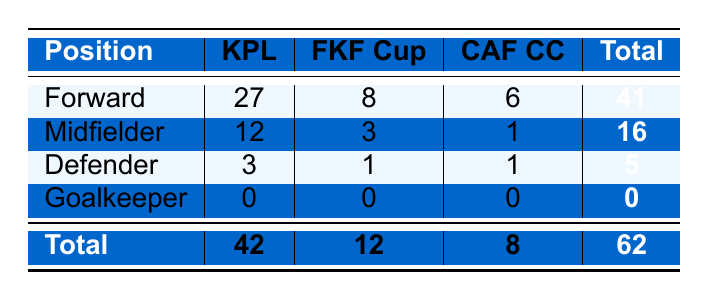What is the total number of goals scored by Kibera Black Stars in the Kenyan Premier League? From the table, the total goals scored by the team in the Kenyan Premier League is indicated in the row for "Total," which shows 42 goals.
Answer: 42 How many goals did midfielders score in the FKF Cup? The row for midfielders shows the FKF Cup goals, which is 3.
Answer: 3 Who scored more goals in the CAF Confederation Cup, forwards or midfielders? Forwards scored 6 goals in the CAF Confederation Cup while midfielders only scored 1 goal. This means forwards scored more.
Answer: Forwards What is the combined total of goals scored by defenders in all competitions? The table shows that defenders scored 3 goals in the Kenyan Premier League, 1 in the FKF Cup, and 1 in the CAF Confederation Cup. Adding these gives 3 + 1 + 1 = 5.
Answer: 5 How many total goals did the Kibera Black Stars score across all competitions? The "Total" row in the table shows the overall number of goals scored by Kibera Black Stars, which is 62.
Answer: 62 Did any goalkeepers score goals for Kibera Black Stars in any competition? The table shows that the row for goalkeepers indicates 0 goals in all competitions, confirming that no goalkeeper scored any goals.
Answer: No Which position has the highest total number of goals scored? Looking at the total goals for each position, forwards with 41 goals have the highest total, followed by midfielders with 16, defenders with 5, and goalkeepers with 0.
Answer: Forwards What is the ratio of goals scored by defenders to those scored by midfielders in the Kenyan Premier League? Defenders scored 3 goals and midfielders scored 12 goals in the Kenyan Premier League. The ratio is 3:12, which simplifies to 1:4.
Answer: 1:4 If a forward scored 1 more goal in the FKF Cup, how many total goals would forwards have scored? Forwards currently have 8 goals in the FKF Cup. If one more goal is added, that would make it 8 + 1 = 9 goals.
Answer: 9 What percentage of Kibera Black Stars' total goals are scored by midfielders? Midfielders scored 16 goals out of a total of 62 goals. To find the percentage, calculate (16 / 62) * 100, which is approximately 25.81%.
Answer: 25.81% 